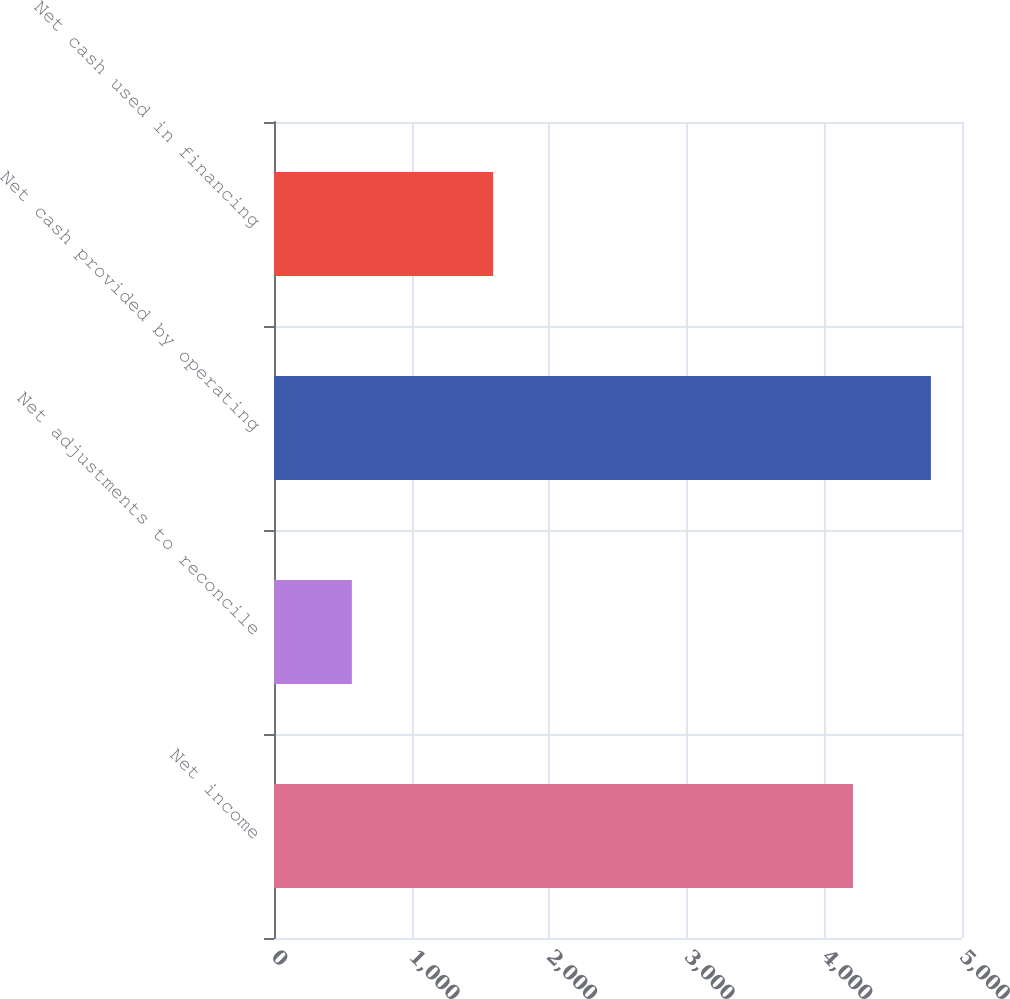<chart> <loc_0><loc_0><loc_500><loc_500><bar_chart><fcel>Net income<fcel>Net adjustments to reconcile<fcel>Net cash provided by operating<fcel>Net cash used in financing<nl><fcel>4208<fcel>566<fcel>4774<fcel>1593<nl></chart> 